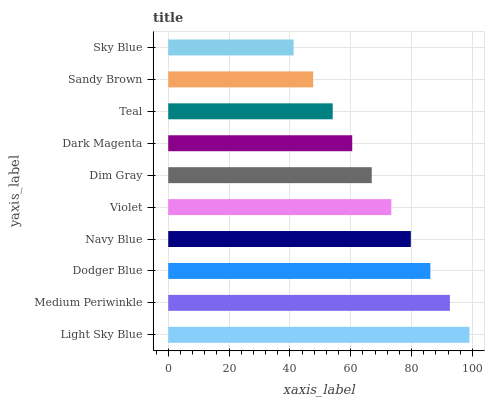Is Sky Blue the minimum?
Answer yes or no. Yes. Is Light Sky Blue the maximum?
Answer yes or no. Yes. Is Medium Periwinkle the minimum?
Answer yes or no. No. Is Medium Periwinkle the maximum?
Answer yes or no. No. Is Light Sky Blue greater than Medium Periwinkle?
Answer yes or no. Yes. Is Medium Periwinkle less than Light Sky Blue?
Answer yes or no. Yes. Is Medium Periwinkle greater than Light Sky Blue?
Answer yes or no. No. Is Light Sky Blue less than Medium Periwinkle?
Answer yes or no. No. Is Violet the high median?
Answer yes or no. Yes. Is Dim Gray the low median?
Answer yes or no. Yes. Is Sky Blue the high median?
Answer yes or no. No. Is Sky Blue the low median?
Answer yes or no. No. 